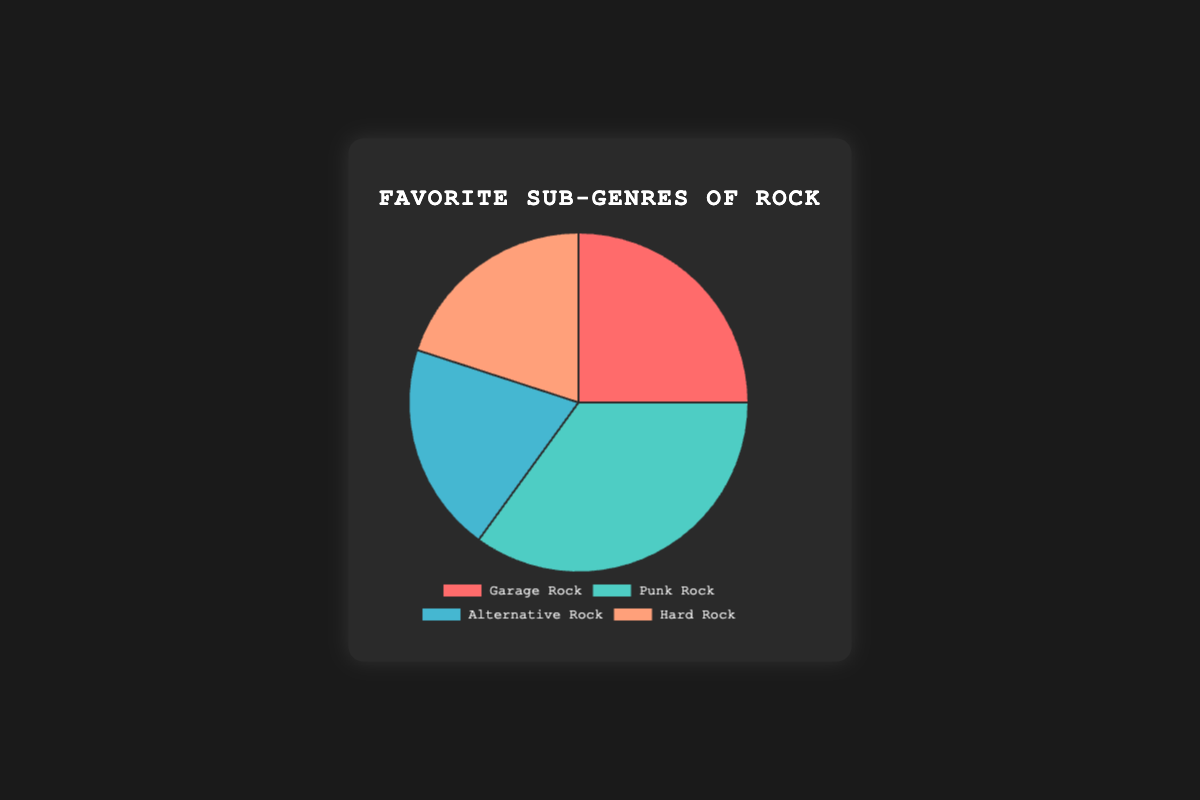What is the most popular rock sub-genre? By looking at the pie chart, we find that Punk Rock has the largest segment, meaning it is the most popular sub-genre among the given options.
Answer: Punk Rock What percentage of enthusiasts prefer Garage Rock? Referring to the pie chart, the slice corresponding to Garage Rock is labeled as 25%.
Answer: 25% How does the popularity of Alternative Rock compare to Hard Rock? According to the chart, both Alternative Rock and Hard Rock have the same segment size, each contributing 20% to the total.
Answer: They are equal What is the combined percentage of enthusiasts who prefer Punk Rock and Garage Rock? Punk Rock accounts for 35% and Garage Rock accounts for 25%. Adding these two percentages gives us: 35 + 25 = 60%.
Answer: 60% Which color represents the Hard Rock segment? Observing the pie chart, Hard Rock is denoted by a slice colored in a shade of orange.
Answer: Orange Which sub-genre is the least popular? The pie chart shows that both Alternative Rock and Hard Rock have the smallest segments, each contributing 20%, making them the least popular.
Answer: Alternative Rock and Hard Rock What is the difference between the percentages of Punk Rock and Alternative Rock? The percentage for Punk Rock is 35% and for Alternative Rock is 20%. The difference is calculated as 35 - 20 = 15%.
Answer: 15% If Alternative Rock and Hard Rock were combined into one category, what would the new percentage be? Both Alternative Rock and Hard Rock individually account for 20% each. Combined, the new category would be: 20 + 20 = 40%.
Answer: 40% Identify the segment with the most green shade. Referring to the colors in the pie chart, the green shade represents Punk Rock.
Answer: Punk Rock 